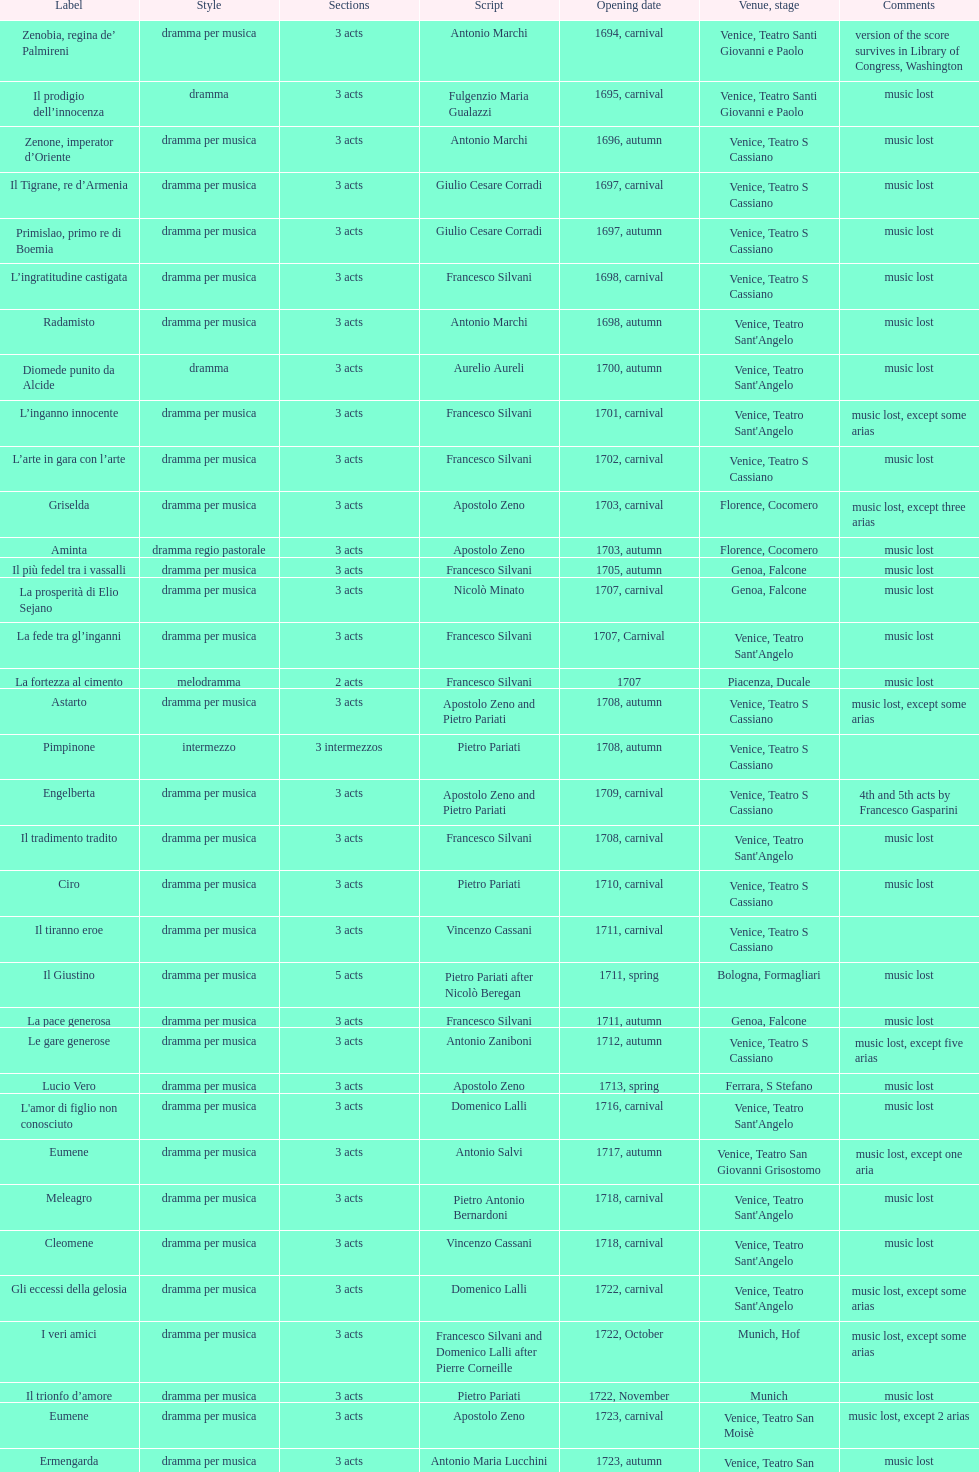Which was released earlier, artamene or merope? Merope. 